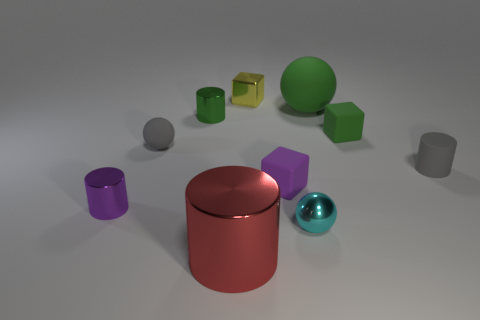How many tiny matte balls are the same color as the small matte cylinder?
Offer a terse response. 1. How many red things are either small spheres or objects?
Ensure brevity in your answer.  1. Is the number of yellow cubes in front of the tiny gray sphere less than the number of tiny green rubber blocks in front of the big green rubber sphere?
Offer a very short reply. Yes. Is there a red metallic object of the same size as the cyan metal object?
Make the answer very short. No. There is a cylinder that is in front of the purple cylinder; is it the same size as the yellow block?
Provide a succinct answer. No. Is the number of small shiny balls greater than the number of things?
Offer a very short reply. No. Are there any red things that have the same shape as the purple rubber thing?
Offer a terse response. No. There is a small purple object that is on the left side of the red cylinder; what is its shape?
Your answer should be very brief. Cylinder. What number of small purple cubes are behind the small metal object that is left of the gray matte object left of the large cylinder?
Your response must be concise. 1. Does the small metallic cylinder behind the purple matte thing have the same color as the small shiny sphere?
Keep it short and to the point. No. 